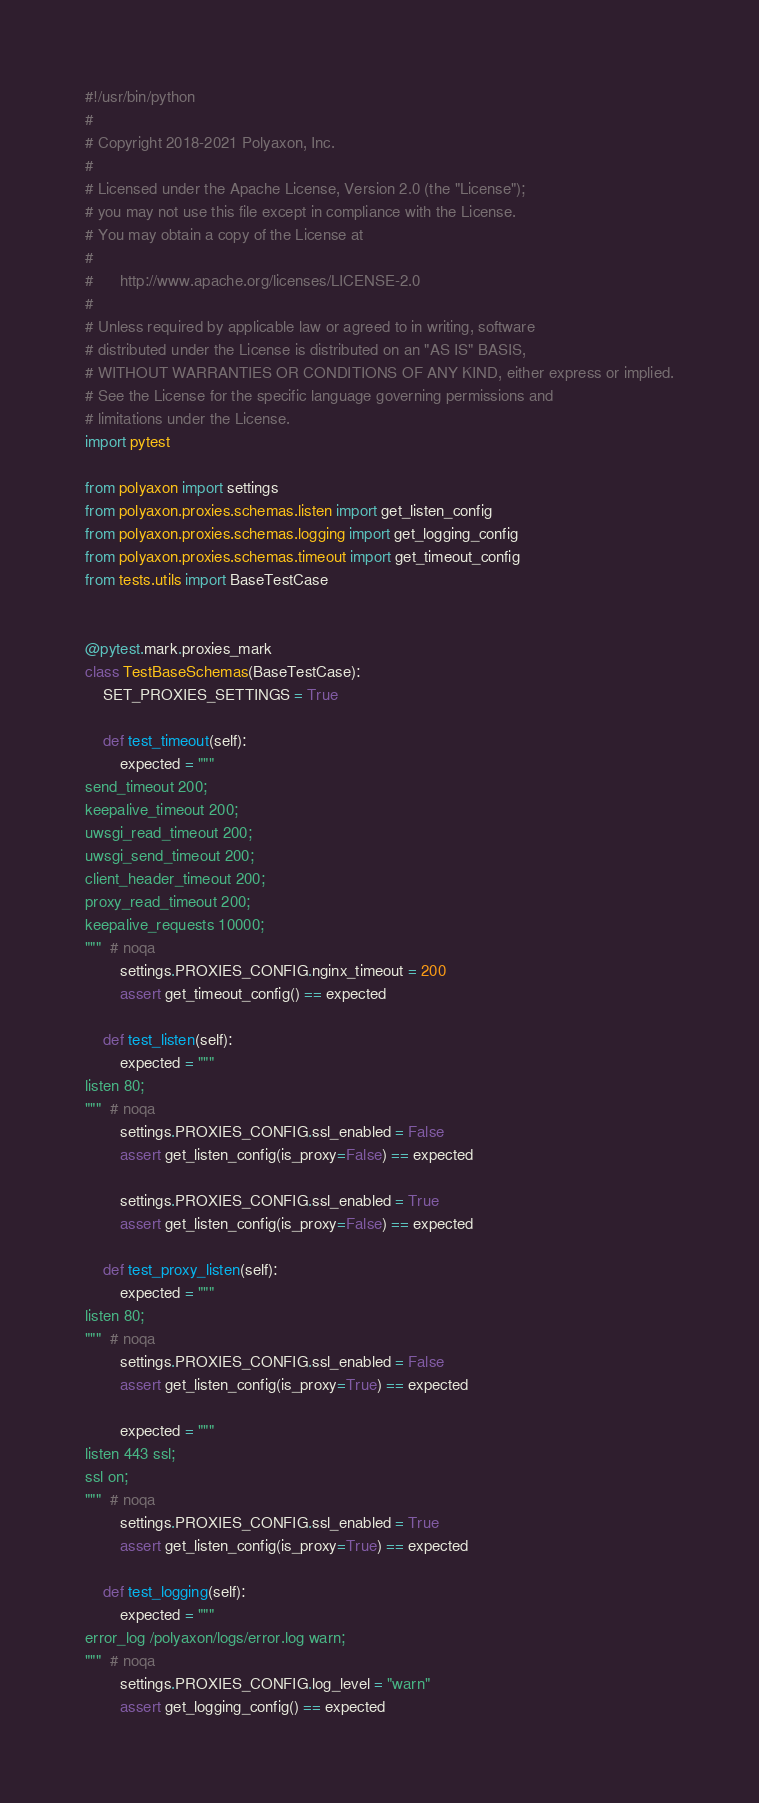<code> <loc_0><loc_0><loc_500><loc_500><_Python_>#!/usr/bin/python
#
# Copyright 2018-2021 Polyaxon, Inc.
#
# Licensed under the Apache License, Version 2.0 (the "License");
# you may not use this file except in compliance with the License.
# You may obtain a copy of the License at
#
#      http://www.apache.org/licenses/LICENSE-2.0
#
# Unless required by applicable law or agreed to in writing, software
# distributed under the License is distributed on an "AS IS" BASIS,
# WITHOUT WARRANTIES OR CONDITIONS OF ANY KIND, either express or implied.
# See the License for the specific language governing permissions and
# limitations under the License.
import pytest

from polyaxon import settings
from polyaxon.proxies.schemas.listen import get_listen_config
from polyaxon.proxies.schemas.logging import get_logging_config
from polyaxon.proxies.schemas.timeout import get_timeout_config
from tests.utils import BaseTestCase


@pytest.mark.proxies_mark
class TestBaseSchemas(BaseTestCase):
    SET_PROXIES_SETTINGS = True

    def test_timeout(self):
        expected = """
send_timeout 200;
keepalive_timeout 200;
uwsgi_read_timeout 200;
uwsgi_send_timeout 200;
client_header_timeout 200;
proxy_read_timeout 200;
keepalive_requests 10000;
"""  # noqa
        settings.PROXIES_CONFIG.nginx_timeout = 200
        assert get_timeout_config() == expected

    def test_listen(self):
        expected = """
listen 80;
"""  # noqa
        settings.PROXIES_CONFIG.ssl_enabled = False
        assert get_listen_config(is_proxy=False) == expected

        settings.PROXIES_CONFIG.ssl_enabled = True
        assert get_listen_config(is_proxy=False) == expected

    def test_proxy_listen(self):
        expected = """
listen 80;
"""  # noqa
        settings.PROXIES_CONFIG.ssl_enabled = False
        assert get_listen_config(is_proxy=True) == expected

        expected = """
listen 443 ssl;
ssl on;
"""  # noqa
        settings.PROXIES_CONFIG.ssl_enabled = True
        assert get_listen_config(is_proxy=True) == expected

    def test_logging(self):
        expected = """
error_log /polyaxon/logs/error.log warn;
"""  # noqa
        settings.PROXIES_CONFIG.log_level = "warn"
        assert get_logging_config() == expected
</code> 